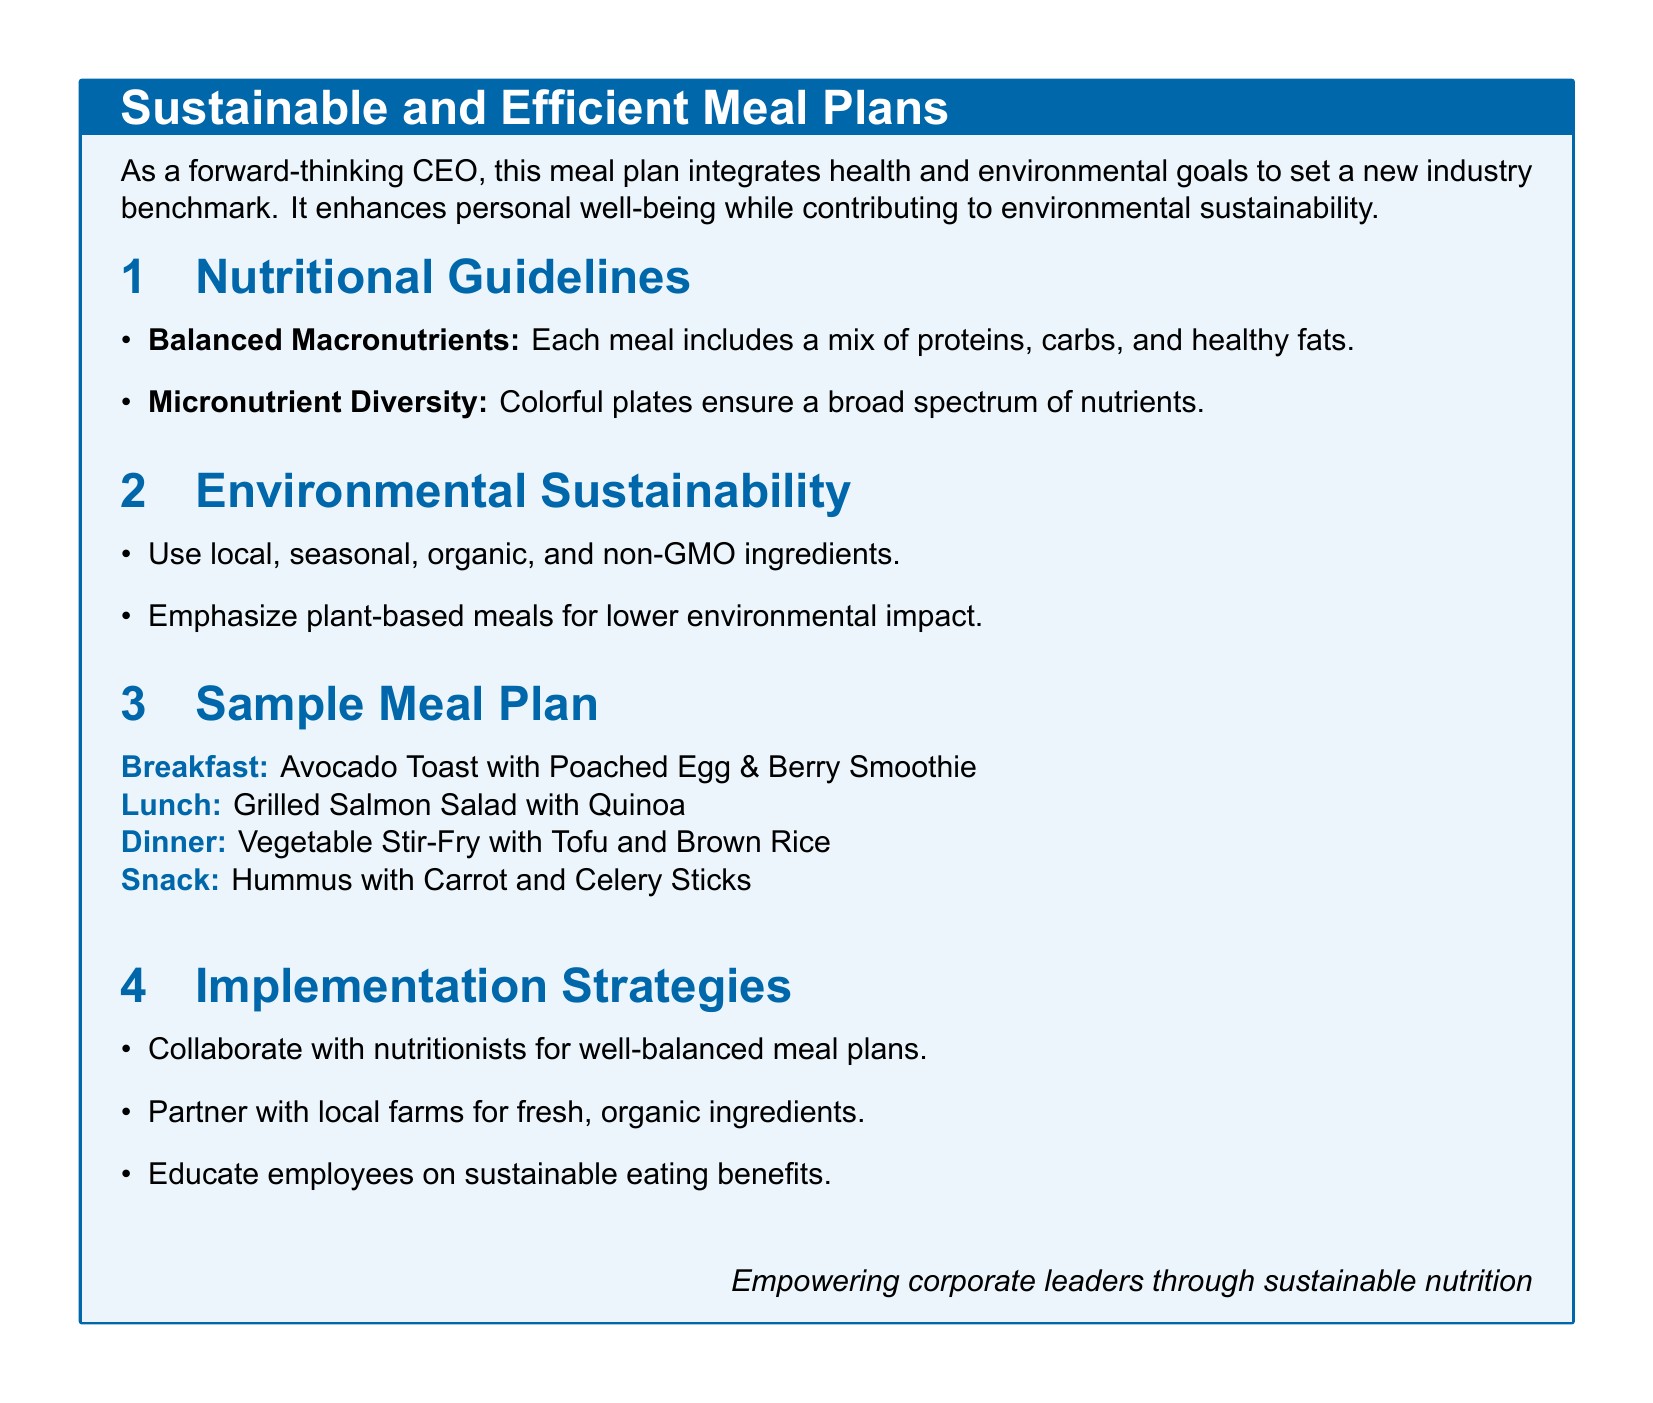What are the main nutritional guidelines? The main nutritional guidelines include balanced macronutrients and micronutrient diversity.
Answer: Balanced macronutrients, micronutrient diversity What is included in the breakfast meal? The breakfast meal consists of Avocado Toast with Poached Egg and Berry Smoothie.
Answer: Avocado Toast with Poached Egg & Berry Smoothie Which meal features grilled salmon? The lunch meal features grilled salmon as part of the Grilled Salmon Salad with Quinoa.
Answer: Lunch What is emphasized to lower environmental impact? The document emphasizes plant-based meals to lower environmental impact.
Answer: Plant-based meals How should the organization collaborate for meal plans? The organization should collaborate with nutritionists for well-balanced meal plans.
Answer: Nutritionists What is one type of ingredient that should be used? One type of ingredient that should be used is local, seasonal, organic, and non-GMO ingredients.
Answer: Local, seasonal, organic, non-GMO What is the purpose of educating employees? The purpose is to inform employees about the benefits of sustainable eating.
Answer: Benefits of sustainable eating What type of meal is served for dinner? The dinner meal is a Vegetable Stir-Fry with Tofu and Brown Rice.
Answer: Vegetable Stir-Fry with Tofu and Brown Rice 